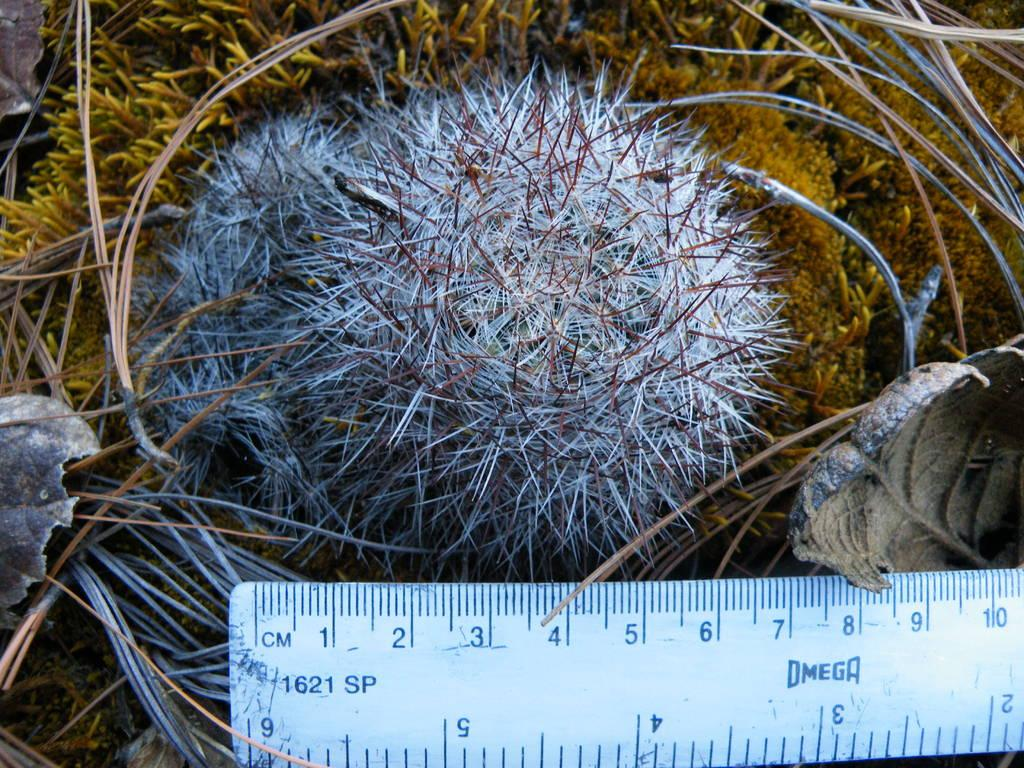<image>
Give a short and clear explanation of the subsequent image. A round plant measures around 7 centimeters across. 